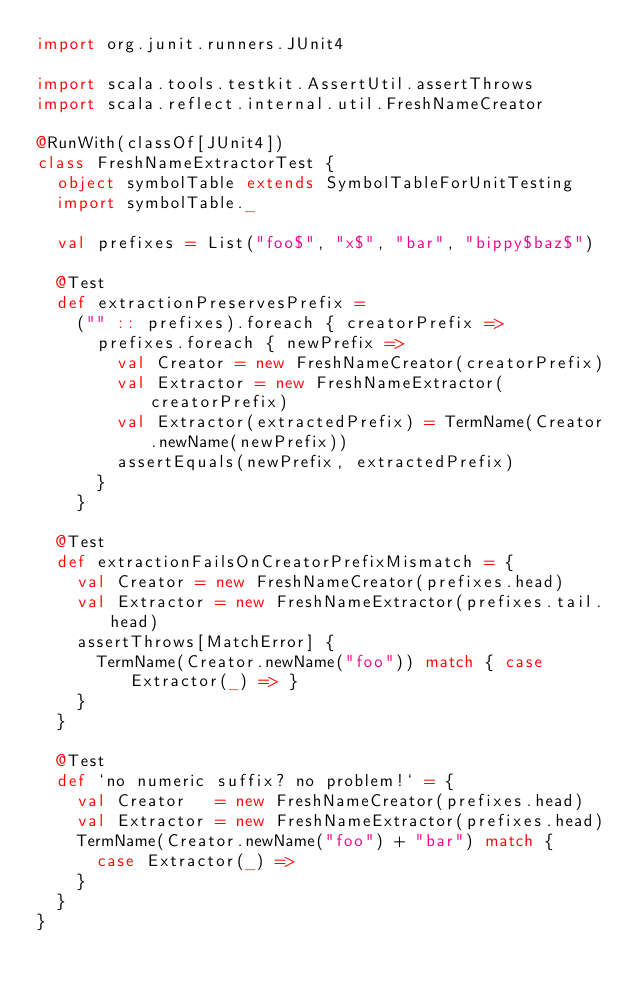Convert code to text. <code><loc_0><loc_0><loc_500><loc_500><_Scala_>import org.junit.runners.JUnit4

import scala.tools.testkit.AssertUtil.assertThrows
import scala.reflect.internal.util.FreshNameCreator

@RunWith(classOf[JUnit4])
class FreshNameExtractorTest {
  object symbolTable extends SymbolTableForUnitTesting
  import symbolTable._

  val prefixes = List("foo$", "x$", "bar", "bippy$baz$")

  @Test
  def extractionPreservesPrefix =
    ("" :: prefixes).foreach { creatorPrefix =>
      prefixes.foreach { newPrefix =>
        val Creator = new FreshNameCreator(creatorPrefix)
        val Extractor = new FreshNameExtractor(creatorPrefix)
        val Extractor(extractedPrefix) = TermName(Creator.newName(newPrefix))
        assertEquals(newPrefix, extractedPrefix)
      }
    }

  @Test
  def extractionFailsOnCreatorPrefixMismatch = {
    val Creator = new FreshNameCreator(prefixes.head)
    val Extractor = new FreshNameExtractor(prefixes.tail.head)
    assertThrows[MatchError] {
      TermName(Creator.newName("foo")) match { case Extractor(_) => }
    }
  }

  @Test
  def `no numeric suffix? no problem!` = {
    val Creator   = new FreshNameCreator(prefixes.head)
    val Extractor = new FreshNameExtractor(prefixes.head)
    TermName(Creator.newName("foo") + "bar") match {
      case Extractor(_) =>
    }
  }
}
</code> 